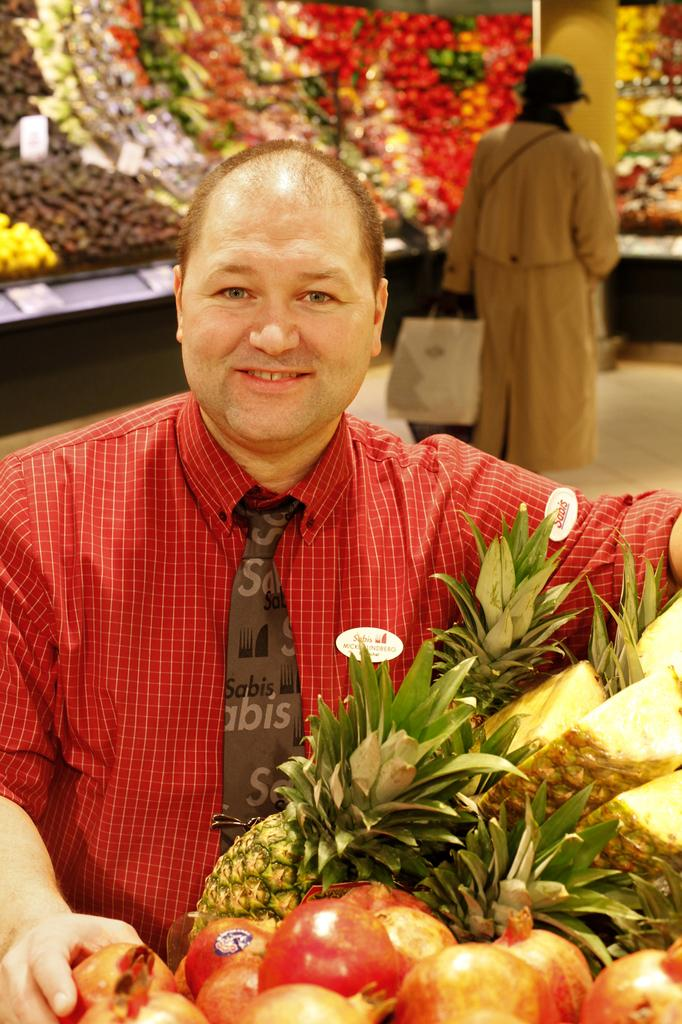What is the main subject of the image? There is a person standing in the image. What is the person wearing? The person is wearing a red shirt. What other objects or items can be seen in the image? There are different fruits visible in the image. Can you describe the person in the background of the image? There is a person holding a bag in the background of the image. What type of meeting is taking place in the image? There is no meeting present in the image; it features a person standing and different fruits. How is the church involved in the image? There is no church present in the image; it focuses on a person, their clothing, and the fruits. 